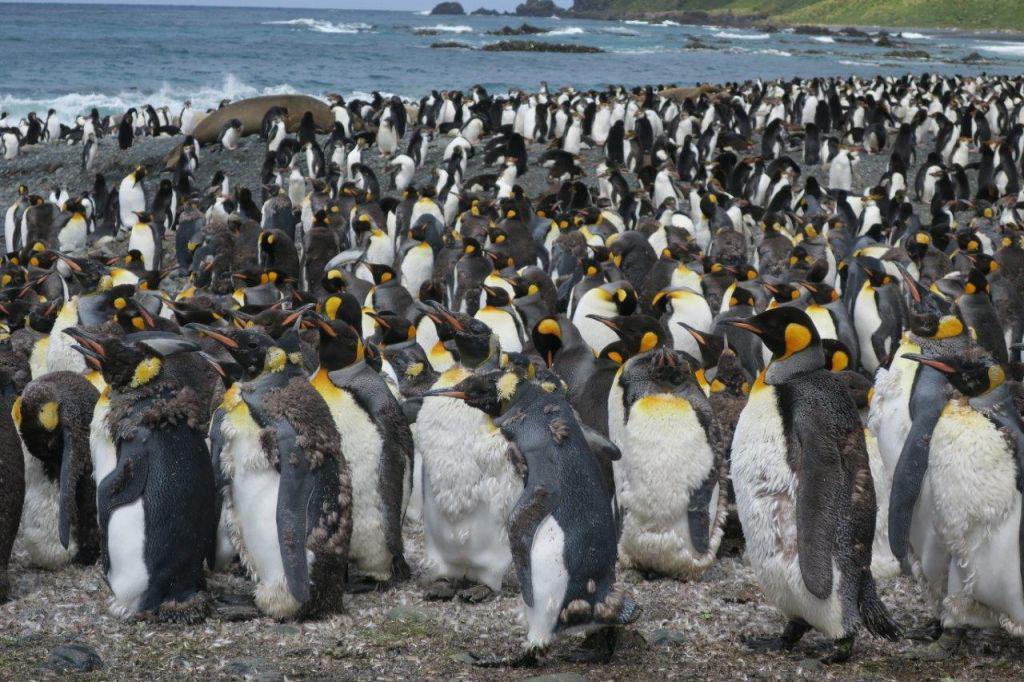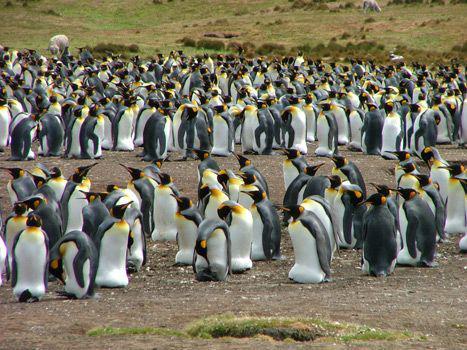The first image is the image on the left, the second image is the image on the right. Analyze the images presented: Is the assertion "A penguin is laying flat on the ground amid a big flock of penguins, in one image." valid? Answer yes or no. No. The first image is the image on the left, the second image is the image on the right. Assess this claim about the two images: "At least one fuzzy brown chick is present.". Correct or not? Answer yes or no. No. 